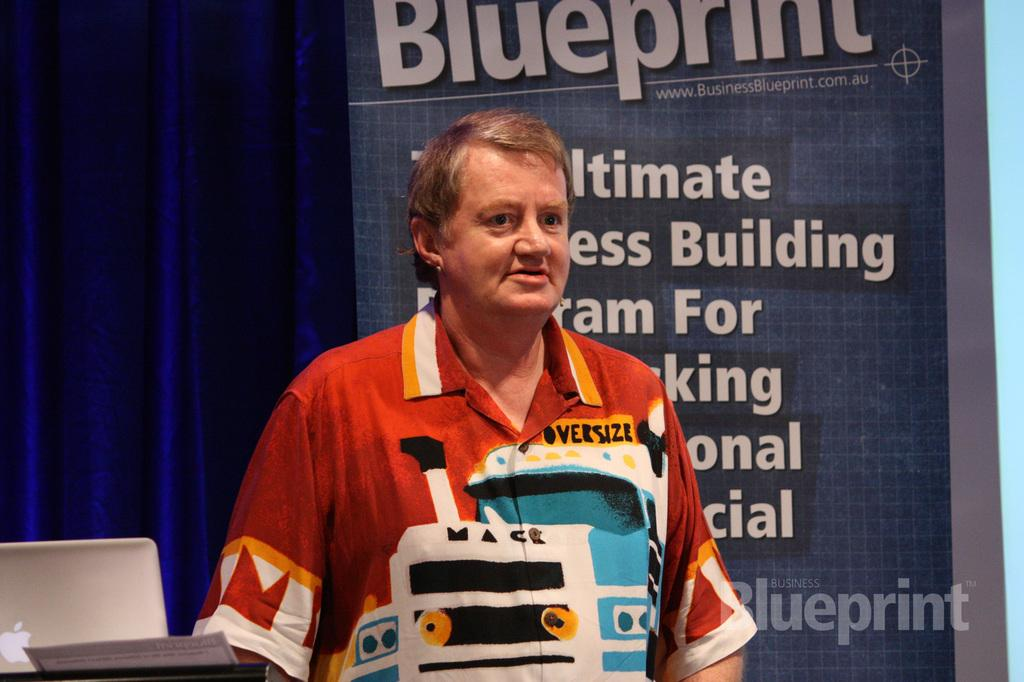<image>
Render a clear and concise summary of the photo. A man in front of a poster with the headline Blueprint. 